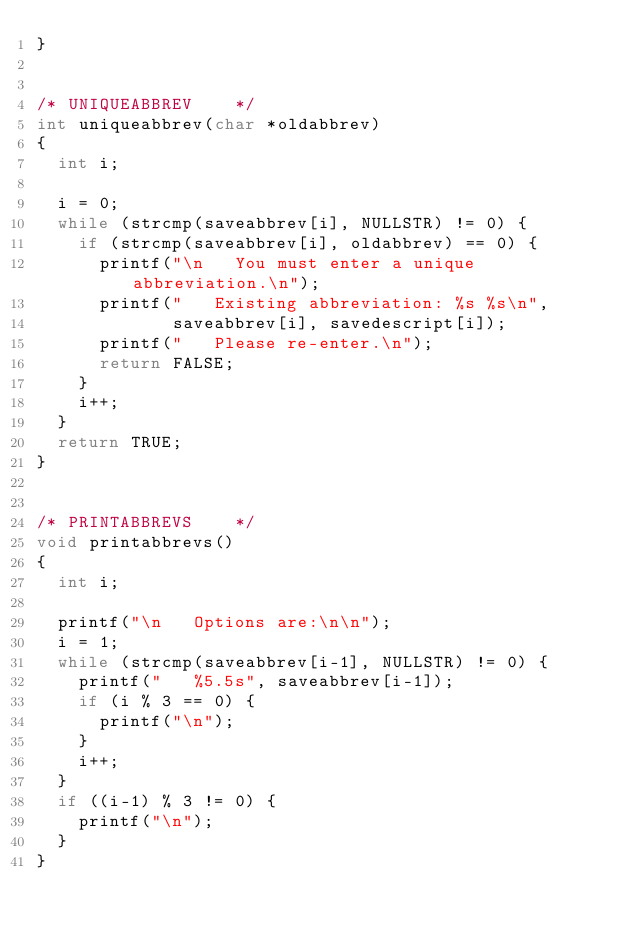<code> <loc_0><loc_0><loc_500><loc_500><_C_>}


/* UNIQUEABBREV    */
int uniqueabbrev(char *oldabbrev)
{
  int i;

  i = 0;
  while (strcmp(saveabbrev[i], NULLSTR) != 0) {
    if (strcmp(saveabbrev[i], oldabbrev) == 0) {
      printf("\n   You must enter a unique abbreviation.\n");
      printf("   Existing abbreviation: %s %s\n", 
             saveabbrev[i], savedescript[i]);
      printf("   Please re-enter.\n");
      return FALSE;
    }
    i++;
  }
  return TRUE;
}


/* PRINTABBREVS    */
void printabbrevs()
{
  int i;

  printf("\n   Options are:\n\n");
  i = 1;
  while (strcmp(saveabbrev[i-1], NULLSTR) != 0) {
    printf("   %5.5s", saveabbrev[i-1]);
    if (i % 3 == 0) {
      printf("\n");
    } 
    i++;
  }
  if ((i-1) % 3 != 0) {
    printf("\n");
  }
}
</code> 